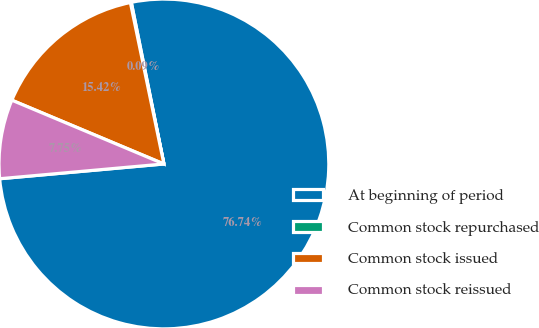Convert chart to OTSL. <chart><loc_0><loc_0><loc_500><loc_500><pie_chart><fcel>At beginning of period<fcel>Common stock repurchased<fcel>Common stock issued<fcel>Common stock reissued<nl><fcel>76.74%<fcel>0.09%<fcel>15.42%<fcel>7.75%<nl></chart> 